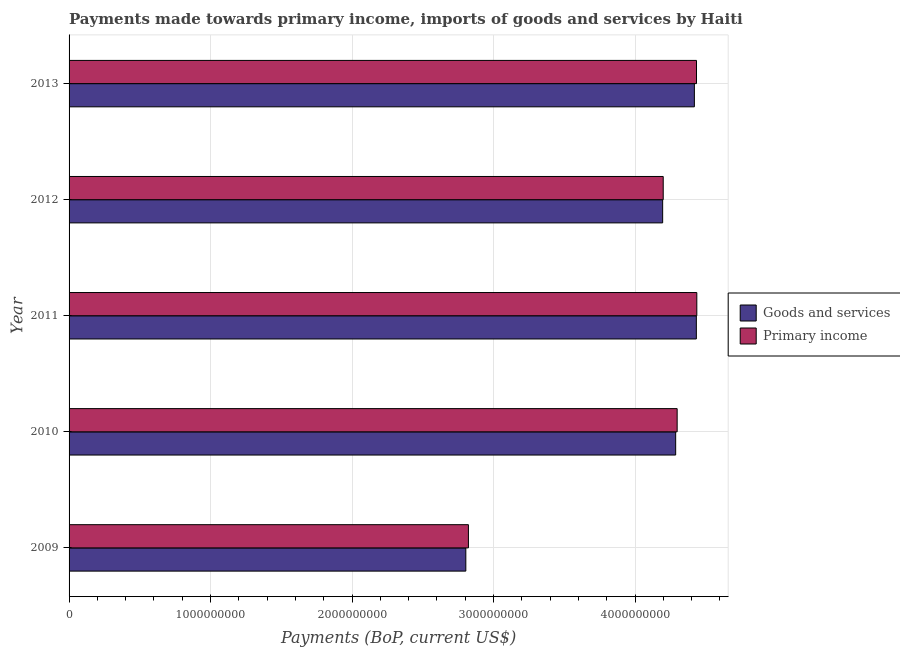How many groups of bars are there?
Keep it short and to the point. 5. Are the number of bars per tick equal to the number of legend labels?
Make the answer very short. Yes. Are the number of bars on each tick of the Y-axis equal?
Ensure brevity in your answer.  Yes. What is the label of the 1st group of bars from the top?
Offer a very short reply. 2013. What is the payments made towards primary income in 2010?
Provide a short and direct response. 4.30e+09. Across all years, what is the maximum payments made towards primary income?
Your answer should be very brief. 4.44e+09. Across all years, what is the minimum payments made towards goods and services?
Keep it short and to the point. 2.80e+09. In which year was the payments made towards primary income maximum?
Offer a very short reply. 2011. In which year was the payments made towards goods and services minimum?
Your response must be concise. 2009. What is the total payments made towards primary income in the graph?
Provide a succinct answer. 2.02e+1. What is the difference between the payments made towards goods and services in 2009 and that in 2010?
Give a very brief answer. -1.48e+09. What is the difference between the payments made towards primary income in 2012 and the payments made towards goods and services in 2013?
Give a very brief answer. -2.20e+08. What is the average payments made towards primary income per year?
Your response must be concise. 4.04e+09. In the year 2011, what is the difference between the payments made towards goods and services and payments made towards primary income?
Your answer should be compact. -3.24e+06. What is the ratio of the payments made towards goods and services in 2012 to that in 2013?
Your answer should be compact. 0.95. Is the payments made towards goods and services in 2009 less than that in 2012?
Give a very brief answer. Yes. What is the difference between the highest and the second highest payments made towards primary income?
Ensure brevity in your answer.  2.16e+06. What is the difference between the highest and the lowest payments made towards goods and services?
Ensure brevity in your answer.  1.63e+09. Is the sum of the payments made towards goods and services in 2010 and 2011 greater than the maximum payments made towards primary income across all years?
Offer a terse response. Yes. What does the 2nd bar from the top in 2009 represents?
Provide a succinct answer. Goods and services. What does the 1st bar from the bottom in 2010 represents?
Your answer should be compact. Goods and services. How many legend labels are there?
Provide a succinct answer. 2. How are the legend labels stacked?
Offer a terse response. Vertical. What is the title of the graph?
Your answer should be very brief. Payments made towards primary income, imports of goods and services by Haiti. What is the label or title of the X-axis?
Your answer should be compact. Payments (BoP, current US$). What is the label or title of the Y-axis?
Your response must be concise. Year. What is the Payments (BoP, current US$) of Goods and services in 2009?
Offer a very short reply. 2.80e+09. What is the Payments (BoP, current US$) in Primary income in 2009?
Ensure brevity in your answer.  2.82e+09. What is the Payments (BoP, current US$) in Goods and services in 2010?
Ensure brevity in your answer.  4.29e+09. What is the Payments (BoP, current US$) of Primary income in 2010?
Keep it short and to the point. 4.30e+09. What is the Payments (BoP, current US$) in Goods and services in 2011?
Your response must be concise. 4.43e+09. What is the Payments (BoP, current US$) in Primary income in 2011?
Give a very brief answer. 4.44e+09. What is the Payments (BoP, current US$) in Goods and services in 2012?
Ensure brevity in your answer.  4.20e+09. What is the Payments (BoP, current US$) in Primary income in 2012?
Keep it short and to the point. 4.20e+09. What is the Payments (BoP, current US$) of Goods and services in 2013?
Keep it short and to the point. 4.42e+09. What is the Payments (BoP, current US$) of Primary income in 2013?
Ensure brevity in your answer.  4.43e+09. Across all years, what is the maximum Payments (BoP, current US$) of Goods and services?
Keep it short and to the point. 4.43e+09. Across all years, what is the maximum Payments (BoP, current US$) in Primary income?
Make the answer very short. 4.44e+09. Across all years, what is the minimum Payments (BoP, current US$) of Goods and services?
Provide a succinct answer. 2.80e+09. Across all years, what is the minimum Payments (BoP, current US$) in Primary income?
Ensure brevity in your answer.  2.82e+09. What is the total Payments (BoP, current US$) in Goods and services in the graph?
Offer a very short reply. 2.01e+1. What is the total Payments (BoP, current US$) in Primary income in the graph?
Give a very brief answer. 2.02e+1. What is the difference between the Payments (BoP, current US$) of Goods and services in 2009 and that in 2010?
Your response must be concise. -1.48e+09. What is the difference between the Payments (BoP, current US$) of Primary income in 2009 and that in 2010?
Give a very brief answer. -1.48e+09. What is the difference between the Payments (BoP, current US$) of Goods and services in 2009 and that in 2011?
Provide a short and direct response. -1.63e+09. What is the difference between the Payments (BoP, current US$) in Primary income in 2009 and that in 2011?
Provide a short and direct response. -1.61e+09. What is the difference between the Payments (BoP, current US$) of Goods and services in 2009 and that in 2012?
Make the answer very short. -1.39e+09. What is the difference between the Payments (BoP, current US$) in Primary income in 2009 and that in 2012?
Keep it short and to the point. -1.38e+09. What is the difference between the Payments (BoP, current US$) of Goods and services in 2009 and that in 2013?
Offer a terse response. -1.62e+09. What is the difference between the Payments (BoP, current US$) in Primary income in 2009 and that in 2013?
Ensure brevity in your answer.  -1.61e+09. What is the difference between the Payments (BoP, current US$) in Goods and services in 2010 and that in 2011?
Offer a very short reply. -1.46e+08. What is the difference between the Payments (BoP, current US$) of Primary income in 2010 and that in 2011?
Give a very brief answer. -1.39e+08. What is the difference between the Payments (BoP, current US$) of Goods and services in 2010 and that in 2012?
Provide a short and direct response. 9.20e+07. What is the difference between the Payments (BoP, current US$) of Primary income in 2010 and that in 2012?
Provide a succinct answer. 9.84e+07. What is the difference between the Payments (BoP, current US$) in Goods and services in 2010 and that in 2013?
Keep it short and to the point. -1.32e+08. What is the difference between the Payments (BoP, current US$) of Primary income in 2010 and that in 2013?
Provide a succinct answer. -1.37e+08. What is the difference between the Payments (BoP, current US$) in Goods and services in 2011 and that in 2012?
Provide a short and direct response. 2.38e+08. What is the difference between the Payments (BoP, current US$) of Primary income in 2011 and that in 2012?
Provide a succinct answer. 2.37e+08. What is the difference between the Payments (BoP, current US$) of Goods and services in 2011 and that in 2013?
Ensure brevity in your answer.  1.40e+07. What is the difference between the Payments (BoP, current US$) of Primary income in 2011 and that in 2013?
Give a very brief answer. 2.16e+06. What is the difference between the Payments (BoP, current US$) of Goods and services in 2012 and that in 2013?
Make the answer very short. -2.24e+08. What is the difference between the Payments (BoP, current US$) of Primary income in 2012 and that in 2013?
Give a very brief answer. -2.35e+08. What is the difference between the Payments (BoP, current US$) of Goods and services in 2009 and the Payments (BoP, current US$) of Primary income in 2010?
Ensure brevity in your answer.  -1.49e+09. What is the difference between the Payments (BoP, current US$) of Goods and services in 2009 and the Payments (BoP, current US$) of Primary income in 2011?
Provide a succinct answer. -1.63e+09. What is the difference between the Payments (BoP, current US$) in Goods and services in 2009 and the Payments (BoP, current US$) in Primary income in 2012?
Provide a succinct answer. -1.40e+09. What is the difference between the Payments (BoP, current US$) of Goods and services in 2009 and the Payments (BoP, current US$) of Primary income in 2013?
Your answer should be very brief. -1.63e+09. What is the difference between the Payments (BoP, current US$) in Goods and services in 2010 and the Payments (BoP, current US$) in Primary income in 2011?
Keep it short and to the point. -1.49e+08. What is the difference between the Payments (BoP, current US$) in Goods and services in 2010 and the Payments (BoP, current US$) in Primary income in 2012?
Offer a very short reply. 8.80e+07. What is the difference between the Payments (BoP, current US$) of Goods and services in 2010 and the Payments (BoP, current US$) of Primary income in 2013?
Your response must be concise. -1.47e+08. What is the difference between the Payments (BoP, current US$) of Goods and services in 2011 and the Payments (BoP, current US$) of Primary income in 2012?
Your answer should be compact. 2.34e+08. What is the difference between the Payments (BoP, current US$) of Goods and services in 2011 and the Payments (BoP, current US$) of Primary income in 2013?
Give a very brief answer. -1.08e+06. What is the difference between the Payments (BoP, current US$) in Goods and services in 2012 and the Payments (BoP, current US$) in Primary income in 2013?
Offer a very short reply. -2.39e+08. What is the average Payments (BoP, current US$) of Goods and services per year?
Provide a short and direct response. 4.03e+09. What is the average Payments (BoP, current US$) of Primary income per year?
Your response must be concise. 4.04e+09. In the year 2009, what is the difference between the Payments (BoP, current US$) of Goods and services and Payments (BoP, current US$) of Primary income?
Make the answer very short. -1.83e+07. In the year 2010, what is the difference between the Payments (BoP, current US$) of Goods and services and Payments (BoP, current US$) of Primary income?
Ensure brevity in your answer.  -1.04e+07. In the year 2011, what is the difference between the Payments (BoP, current US$) of Goods and services and Payments (BoP, current US$) of Primary income?
Your response must be concise. -3.24e+06. In the year 2012, what is the difference between the Payments (BoP, current US$) of Goods and services and Payments (BoP, current US$) of Primary income?
Ensure brevity in your answer.  -3.96e+06. In the year 2013, what is the difference between the Payments (BoP, current US$) in Goods and services and Payments (BoP, current US$) in Primary income?
Keep it short and to the point. -1.50e+07. What is the ratio of the Payments (BoP, current US$) in Goods and services in 2009 to that in 2010?
Offer a terse response. 0.65. What is the ratio of the Payments (BoP, current US$) of Primary income in 2009 to that in 2010?
Keep it short and to the point. 0.66. What is the ratio of the Payments (BoP, current US$) of Goods and services in 2009 to that in 2011?
Ensure brevity in your answer.  0.63. What is the ratio of the Payments (BoP, current US$) in Primary income in 2009 to that in 2011?
Offer a terse response. 0.64. What is the ratio of the Payments (BoP, current US$) of Goods and services in 2009 to that in 2012?
Your answer should be compact. 0.67. What is the ratio of the Payments (BoP, current US$) of Primary income in 2009 to that in 2012?
Your answer should be compact. 0.67. What is the ratio of the Payments (BoP, current US$) of Goods and services in 2009 to that in 2013?
Your response must be concise. 0.63. What is the ratio of the Payments (BoP, current US$) of Primary income in 2009 to that in 2013?
Offer a very short reply. 0.64. What is the ratio of the Payments (BoP, current US$) of Goods and services in 2010 to that in 2011?
Your response must be concise. 0.97. What is the ratio of the Payments (BoP, current US$) of Primary income in 2010 to that in 2011?
Offer a terse response. 0.97. What is the ratio of the Payments (BoP, current US$) of Goods and services in 2010 to that in 2012?
Provide a short and direct response. 1.02. What is the ratio of the Payments (BoP, current US$) in Primary income in 2010 to that in 2012?
Keep it short and to the point. 1.02. What is the ratio of the Payments (BoP, current US$) in Goods and services in 2010 to that in 2013?
Your answer should be very brief. 0.97. What is the ratio of the Payments (BoP, current US$) in Primary income in 2010 to that in 2013?
Make the answer very short. 0.97. What is the ratio of the Payments (BoP, current US$) in Goods and services in 2011 to that in 2012?
Provide a succinct answer. 1.06. What is the ratio of the Payments (BoP, current US$) of Primary income in 2011 to that in 2012?
Your answer should be very brief. 1.06. What is the ratio of the Payments (BoP, current US$) of Primary income in 2011 to that in 2013?
Give a very brief answer. 1. What is the ratio of the Payments (BoP, current US$) of Goods and services in 2012 to that in 2013?
Ensure brevity in your answer.  0.95. What is the ratio of the Payments (BoP, current US$) of Primary income in 2012 to that in 2013?
Offer a very short reply. 0.95. What is the difference between the highest and the second highest Payments (BoP, current US$) in Goods and services?
Ensure brevity in your answer.  1.40e+07. What is the difference between the highest and the second highest Payments (BoP, current US$) in Primary income?
Make the answer very short. 2.16e+06. What is the difference between the highest and the lowest Payments (BoP, current US$) in Goods and services?
Your response must be concise. 1.63e+09. What is the difference between the highest and the lowest Payments (BoP, current US$) in Primary income?
Ensure brevity in your answer.  1.61e+09. 